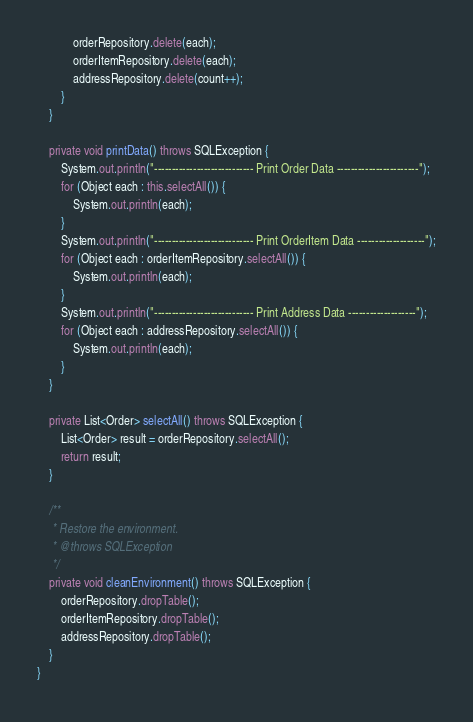<code> <loc_0><loc_0><loc_500><loc_500><_Java_>            orderRepository.delete(each);
            orderItemRepository.delete(each);
            addressRepository.delete(count++);
        }
    }
    
    private void printData() throws SQLException {
        System.out.println("---------------------------- Print Order Data -----------------------");
        for (Object each : this.selectAll()) {
            System.out.println(each);
        }
        System.out.println("---------------------------- Print OrderItem Data -------------------");
        for (Object each : orderItemRepository.selectAll()) {
            System.out.println(each);
        } 
        System.out.println("---------------------------- Print Address Data -------------------");
        for (Object each : addressRepository.selectAll()) {
            System.out.println(each);
        }
    }
    
    private List<Order> selectAll() throws SQLException {
        List<Order> result = orderRepository.selectAll();
        return result;
    }
    
    /**
     * Restore the environment.
     * @throws SQLException
     */
    private void cleanEnvironment() throws SQLException {
        orderRepository.dropTable();
        orderItemRepository.dropTable();
        addressRepository.dropTable();
    }
}
</code> 